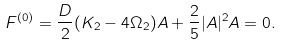Convert formula to latex. <formula><loc_0><loc_0><loc_500><loc_500>F ^ { ( 0 ) } = \frac { D } { 2 } ( K _ { 2 } - 4 \Omega _ { 2 } ) A + \frac { 2 } { 5 } | A | ^ { 2 } A = 0 .</formula> 